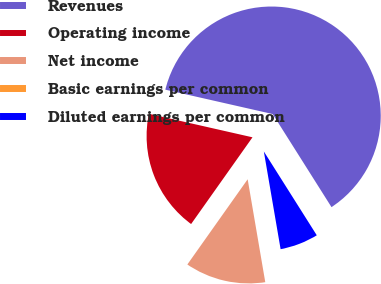<chart> <loc_0><loc_0><loc_500><loc_500><pie_chart><fcel>Revenues<fcel>Operating income<fcel>Net income<fcel>Basic earnings per common<fcel>Diluted earnings per common<nl><fcel>62.48%<fcel>18.75%<fcel>12.5%<fcel>0.01%<fcel>6.26%<nl></chart> 